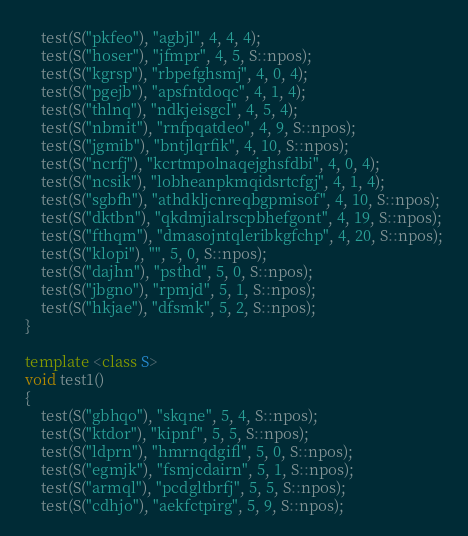<code> <loc_0><loc_0><loc_500><loc_500><_C++_>    test(S("pkfeo"), "agbjl", 4, 4, 4);
    test(S("hoser"), "jfmpr", 4, 5, S::npos);
    test(S("kgrsp"), "rbpefghsmj", 4, 0, 4);
    test(S("pgejb"), "apsfntdoqc", 4, 1, 4);
    test(S("thlnq"), "ndkjeisgcl", 4, 5, 4);
    test(S("nbmit"), "rnfpqatdeo", 4, 9, S::npos);
    test(S("jgmib"), "bntjlqrfik", 4, 10, S::npos);
    test(S("ncrfj"), "kcrtmpolnaqejghsfdbi", 4, 0, 4);
    test(S("ncsik"), "lobheanpkmqidsrtcfgj", 4, 1, 4);
    test(S("sgbfh"), "athdkljcnreqbgpmisof", 4, 10, S::npos);
    test(S("dktbn"), "qkdmjialrscpbhefgont", 4, 19, S::npos);
    test(S("fthqm"), "dmasojntqleribkgfchp", 4, 20, S::npos);
    test(S("klopi"), "", 5, 0, S::npos);
    test(S("dajhn"), "psthd", 5, 0, S::npos);
    test(S("jbgno"), "rpmjd", 5, 1, S::npos);
    test(S("hkjae"), "dfsmk", 5, 2, S::npos);
}

template <class S>
void test1()
{
    test(S("gbhqo"), "skqne", 5, 4, S::npos);
    test(S("ktdor"), "kipnf", 5, 5, S::npos);
    test(S("ldprn"), "hmrnqdgifl", 5, 0, S::npos);
    test(S("egmjk"), "fsmjcdairn", 5, 1, S::npos);
    test(S("armql"), "pcdgltbrfj", 5, 5, S::npos);
    test(S("cdhjo"), "aekfctpirg", 5, 9, S::npos);</code> 